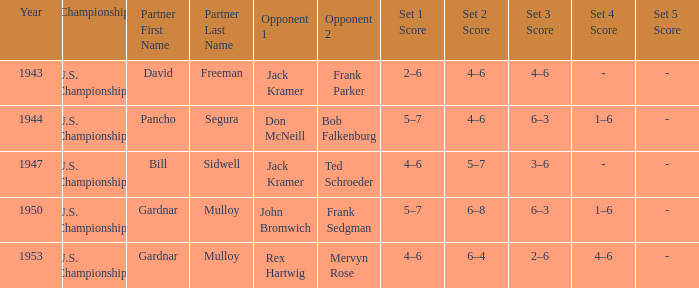What score did opponents achieve in the final of john bromwich frank sedgman? 5–7, 6–8, 6–3, 1–6. 